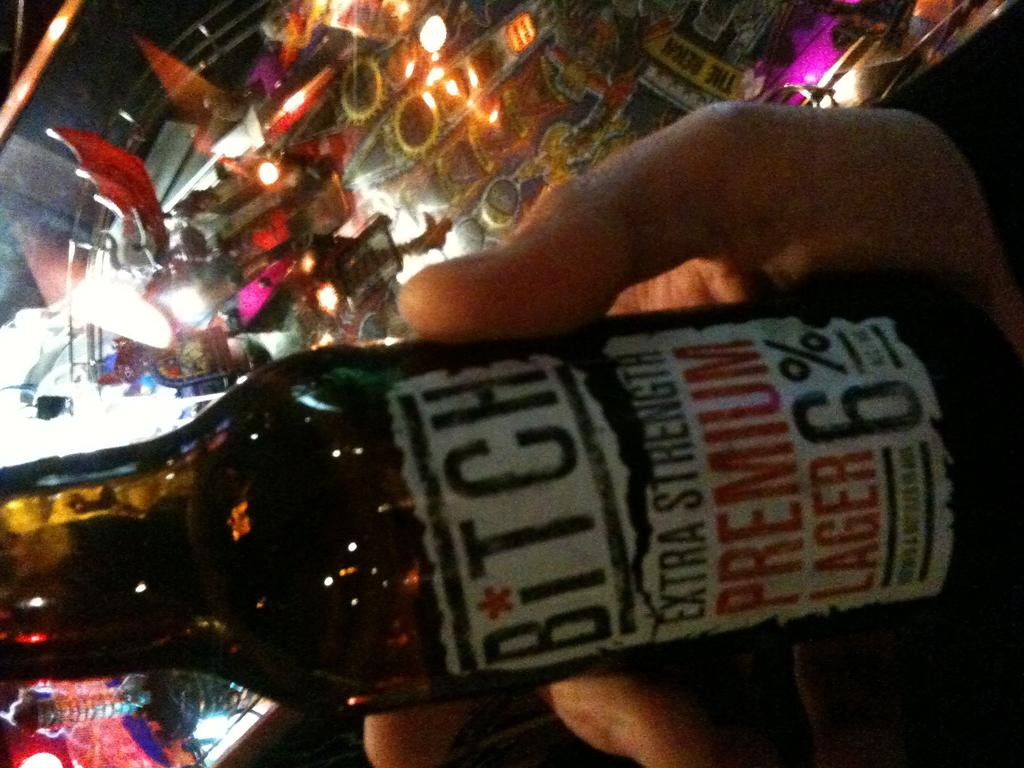<image>
Give a short and clear explanation of the subsequent image. Someone holding a bottle of bitch in a bar 